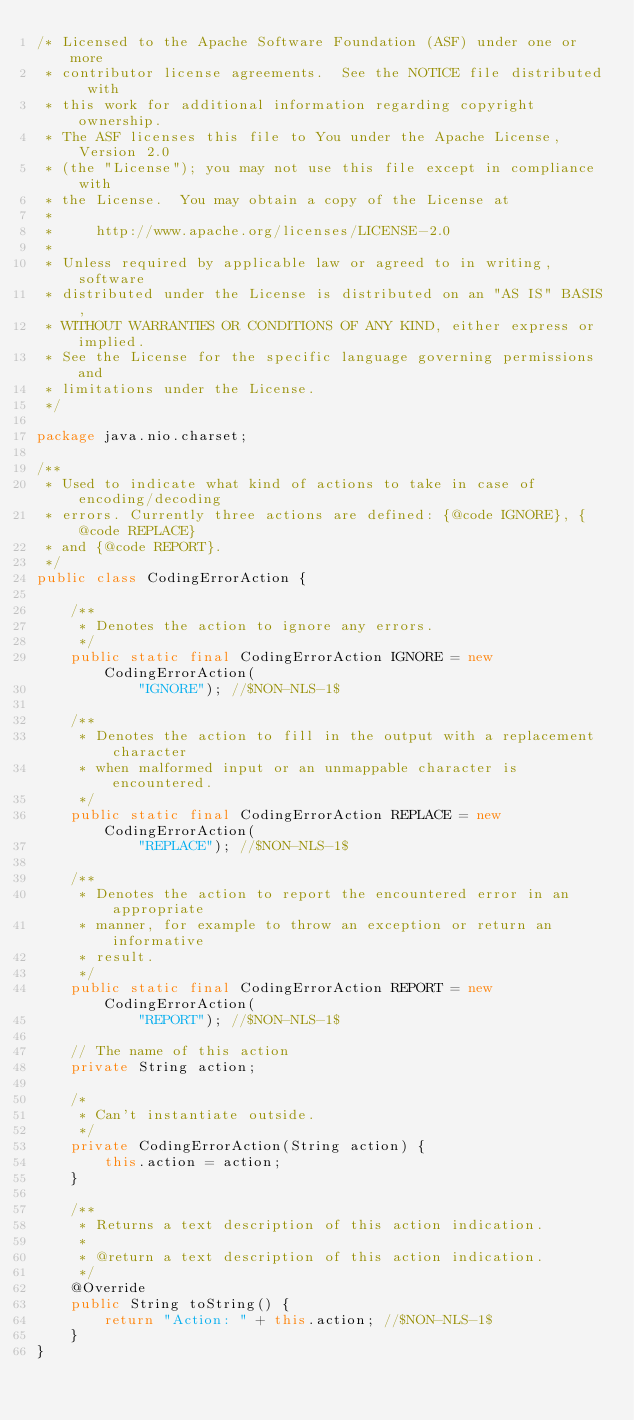Convert code to text. <code><loc_0><loc_0><loc_500><loc_500><_Java_>/* Licensed to the Apache Software Foundation (ASF) under one or more
 * contributor license agreements.  See the NOTICE file distributed with
 * this work for additional information regarding copyright ownership.
 * The ASF licenses this file to You under the Apache License, Version 2.0
 * (the "License"); you may not use this file except in compliance with
 * the License.  You may obtain a copy of the License at
 * 
 *     http://www.apache.org/licenses/LICENSE-2.0
 * 
 * Unless required by applicable law or agreed to in writing, software
 * distributed under the License is distributed on an "AS IS" BASIS,
 * WITHOUT WARRANTIES OR CONDITIONS OF ANY KIND, either express or implied.
 * See the License for the specific language governing permissions and
 * limitations under the License.
 */

package java.nio.charset;

/**
 * Used to indicate what kind of actions to take in case of encoding/decoding
 * errors. Currently three actions are defined: {@code IGNORE}, {@code REPLACE}
 * and {@code REPORT}.
 */
public class CodingErrorAction {

    /**
     * Denotes the action to ignore any errors.
     */
    public static final CodingErrorAction IGNORE = new CodingErrorAction(
            "IGNORE"); //$NON-NLS-1$

    /**
     * Denotes the action to fill in the output with a replacement character
     * when malformed input or an unmappable character is encountered.
     */
    public static final CodingErrorAction REPLACE = new CodingErrorAction(
            "REPLACE"); //$NON-NLS-1$

    /**
     * Denotes the action to report the encountered error in an appropriate
     * manner, for example to throw an exception or return an informative
     * result.
     */
    public static final CodingErrorAction REPORT = new CodingErrorAction(
            "REPORT"); //$NON-NLS-1$

    // The name of this action
    private String action;

    /*
     * Can't instantiate outside.
     */
    private CodingErrorAction(String action) {
        this.action = action;
    }

    /**
     * Returns a text description of this action indication.
     * 
     * @return a text description of this action indication.
     */
    @Override
    public String toString() {
        return "Action: " + this.action; //$NON-NLS-1$
    }
}
</code> 